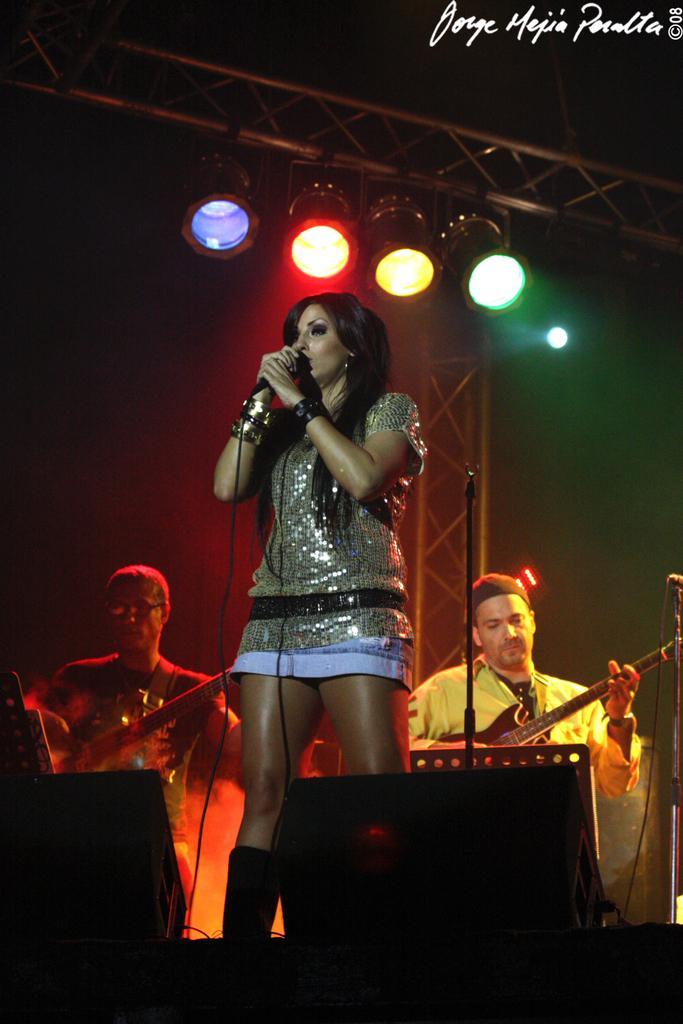Can you describe this image briefly? In this image, we can see woman is holding a microphone. And the background, we can see 2 mens are playing a guitar. Here we can see rods, lights. 